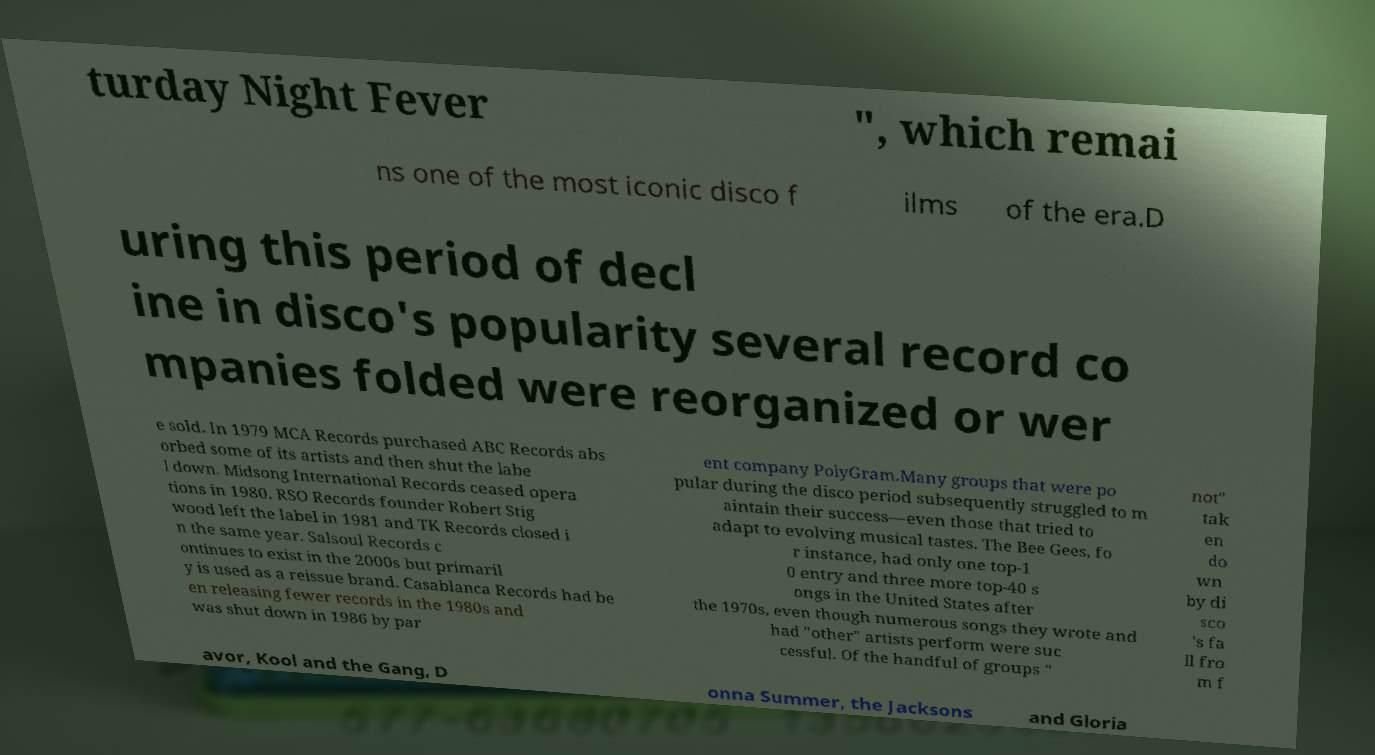Please read and relay the text visible in this image. What does it say? turday Night Fever ", which remai ns one of the most iconic disco f ilms of the era.D uring this period of decl ine in disco's popularity several record co mpanies folded were reorganized or wer e sold. In 1979 MCA Records purchased ABC Records abs orbed some of its artists and then shut the labe l down. Midsong International Records ceased opera tions in 1980. RSO Records founder Robert Stig wood left the label in 1981 and TK Records closed i n the same year. Salsoul Records c ontinues to exist in the 2000s but primaril y is used as a reissue brand. Casablanca Records had be en releasing fewer records in the 1980s and was shut down in 1986 by par ent company PolyGram.Many groups that were po pular during the disco period subsequently struggled to m aintain their success—even those that tried to adapt to evolving musical tastes. The Bee Gees, fo r instance, had only one top-1 0 entry and three more top-40 s ongs in the United States after the 1970s, even though numerous songs they wrote and had "other" artists perform were suc cessful. Of the handful of groups " not" tak en do wn by di sco 's fa ll fro m f avor, Kool and the Gang, D onna Summer, the Jacksons and Gloria 